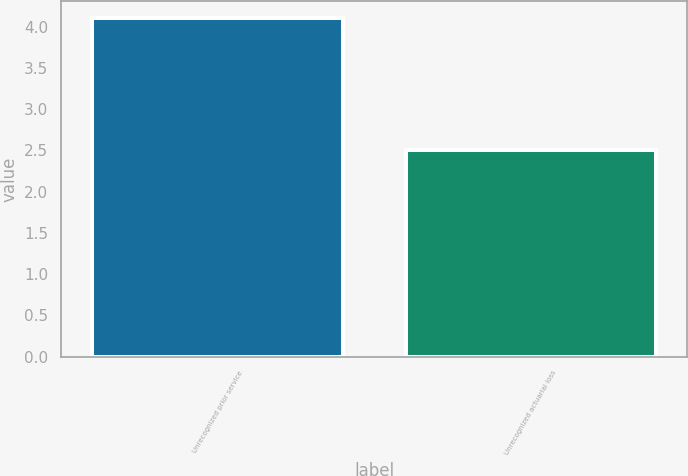Convert chart. <chart><loc_0><loc_0><loc_500><loc_500><bar_chart><fcel>Unrecognized prior service<fcel>Unrecognized actuarial loss<nl><fcel>4.1<fcel>2.5<nl></chart> 